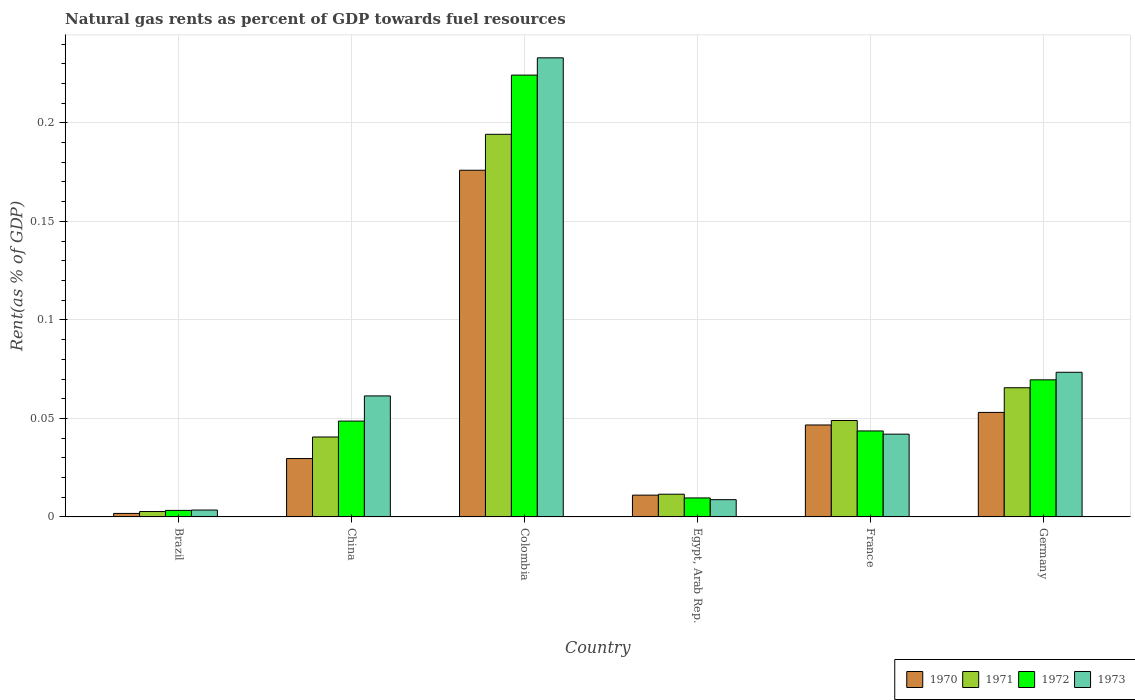How many bars are there on the 6th tick from the left?
Your answer should be very brief. 4. What is the matural gas rent in 1973 in Egypt, Arab Rep.?
Your answer should be very brief. 0.01. Across all countries, what is the maximum matural gas rent in 1970?
Ensure brevity in your answer.  0.18. Across all countries, what is the minimum matural gas rent in 1971?
Ensure brevity in your answer.  0. In which country was the matural gas rent in 1972 maximum?
Provide a short and direct response. Colombia. In which country was the matural gas rent in 1972 minimum?
Provide a succinct answer. Brazil. What is the total matural gas rent in 1970 in the graph?
Provide a succinct answer. 0.32. What is the difference between the matural gas rent in 1973 in Brazil and that in Egypt, Arab Rep.?
Your answer should be very brief. -0.01. What is the difference between the matural gas rent in 1971 in France and the matural gas rent in 1972 in Germany?
Offer a very short reply. -0.02. What is the average matural gas rent in 1970 per country?
Offer a terse response. 0.05. What is the difference between the matural gas rent of/in 1970 and matural gas rent of/in 1971 in China?
Your answer should be very brief. -0.01. In how many countries, is the matural gas rent in 1973 greater than 0.01 %?
Your answer should be compact. 4. What is the ratio of the matural gas rent in 1972 in China to that in Germany?
Keep it short and to the point. 0.7. Is the difference between the matural gas rent in 1970 in Colombia and France greater than the difference between the matural gas rent in 1971 in Colombia and France?
Your answer should be very brief. No. What is the difference between the highest and the second highest matural gas rent in 1972?
Ensure brevity in your answer.  0.15. What is the difference between the highest and the lowest matural gas rent in 1971?
Provide a succinct answer. 0.19. In how many countries, is the matural gas rent in 1973 greater than the average matural gas rent in 1973 taken over all countries?
Provide a short and direct response. 2. What does the 4th bar from the left in Germany represents?
Your response must be concise. 1973. Are all the bars in the graph horizontal?
Provide a short and direct response. No. Where does the legend appear in the graph?
Give a very brief answer. Bottom right. What is the title of the graph?
Your answer should be compact. Natural gas rents as percent of GDP towards fuel resources. Does "1965" appear as one of the legend labels in the graph?
Your answer should be compact. No. What is the label or title of the Y-axis?
Keep it short and to the point. Rent(as % of GDP). What is the Rent(as % of GDP) of 1970 in Brazil?
Your response must be concise. 0. What is the Rent(as % of GDP) in 1971 in Brazil?
Make the answer very short. 0. What is the Rent(as % of GDP) of 1972 in Brazil?
Give a very brief answer. 0. What is the Rent(as % of GDP) of 1973 in Brazil?
Offer a terse response. 0. What is the Rent(as % of GDP) in 1970 in China?
Provide a succinct answer. 0.03. What is the Rent(as % of GDP) of 1971 in China?
Give a very brief answer. 0.04. What is the Rent(as % of GDP) in 1972 in China?
Your response must be concise. 0.05. What is the Rent(as % of GDP) in 1973 in China?
Your answer should be compact. 0.06. What is the Rent(as % of GDP) in 1970 in Colombia?
Offer a very short reply. 0.18. What is the Rent(as % of GDP) of 1971 in Colombia?
Give a very brief answer. 0.19. What is the Rent(as % of GDP) in 1972 in Colombia?
Your response must be concise. 0.22. What is the Rent(as % of GDP) of 1973 in Colombia?
Your answer should be compact. 0.23. What is the Rent(as % of GDP) of 1970 in Egypt, Arab Rep.?
Your answer should be compact. 0.01. What is the Rent(as % of GDP) of 1971 in Egypt, Arab Rep.?
Your response must be concise. 0.01. What is the Rent(as % of GDP) of 1972 in Egypt, Arab Rep.?
Your response must be concise. 0.01. What is the Rent(as % of GDP) of 1973 in Egypt, Arab Rep.?
Keep it short and to the point. 0.01. What is the Rent(as % of GDP) in 1970 in France?
Keep it short and to the point. 0.05. What is the Rent(as % of GDP) of 1971 in France?
Ensure brevity in your answer.  0.05. What is the Rent(as % of GDP) of 1972 in France?
Make the answer very short. 0.04. What is the Rent(as % of GDP) of 1973 in France?
Offer a very short reply. 0.04. What is the Rent(as % of GDP) of 1970 in Germany?
Offer a very short reply. 0.05. What is the Rent(as % of GDP) of 1971 in Germany?
Provide a succinct answer. 0.07. What is the Rent(as % of GDP) in 1972 in Germany?
Offer a very short reply. 0.07. What is the Rent(as % of GDP) in 1973 in Germany?
Keep it short and to the point. 0.07. Across all countries, what is the maximum Rent(as % of GDP) in 1970?
Provide a succinct answer. 0.18. Across all countries, what is the maximum Rent(as % of GDP) in 1971?
Your response must be concise. 0.19. Across all countries, what is the maximum Rent(as % of GDP) in 1972?
Provide a succinct answer. 0.22. Across all countries, what is the maximum Rent(as % of GDP) of 1973?
Offer a very short reply. 0.23. Across all countries, what is the minimum Rent(as % of GDP) of 1970?
Offer a terse response. 0. Across all countries, what is the minimum Rent(as % of GDP) of 1971?
Provide a succinct answer. 0. Across all countries, what is the minimum Rent(as % of GDP) of 1972?
Provide a short and direct response. 0. Across all countries, what is the minimum Rent(as % of GDP) of 1973?
Ensure brevity in your answer.  0. What is the total Rent(as % of GDP) in 1970 in the graph?
Keep it short and to the point. 0.32. What is the total Rent(as % of GDP) of 1971 in the graph?
Keep it short and to the point. 0.36. What is the total Rent(as % of GDP) of 1972 in the graph?
Ensure brevity in your answer.  0.4. What is the total Rent(as % of GDP) of 1973 in the graph?
Provide a short and direct response. 0.42. What is the difference between the Rent(as % of GDP) in 1970 in Brazil and that in China?
Provide a succinct answer. -0.03. What is the difference between the Rent(as % of GDP) in 1971 in Brazil and that in China?
Offer a terse response. -0.04. What is the difference between the Rent(as % of GDP) in 1972 in Brazil and that in China?
Make the answer very short. -0.05. What is the difference between the Rent(as % of GDP) of 1973 in Brazil and that in China?
Your answer should be compact. -0.06. What is the difference between the Rent(as % of GDP) of 1970 in Brazil and that in Colombia?
Your answer should be compact. -0.17. What is the difference between the Rent(as % of GDP) in 1971 in Brazil and that in Colombia?
Ensure brevity in your answer.  -0.19. What is the difference between the Rent(as % of GDP) of 1972 in Brazil and that in Colombia?
Give a very brief answer. -0.22. What is the difference between the Rent(as % of GDP) in 1973 in Brazil and that in Colombia?
Give a very brief answer. -0.23. What is the difference between the Rent(as % of GDP) of 1970 in Brazil and that in Egypt, Arab Rep.?
Make the answer very short. -0.01. What is the difference between the Rent(as % of GDP) in 1971 in Brazil and that in Egypt, Arab Rep.?
Your response must be concise. -0.01. What is the difference between the Rent(as % of GDP) of 1972 in Brazil and that in Egypt, Arab Rep.?
Ensure brevity in your answer.  -0.01. What is the difference between the Rent(as % of GDP) in 1973 in Brazil and that in Egypt, Arab Rep.?
Your response must be concise. -0.01. What is the difference between the Rent(as % of GDP) in 1970 in Brazil and that in France?
Your answer should be compact. -0.04. What is the difference between the Rent(as % of GDP) of 1971 in Brazil and that in France?
Give a very brief answer. -0.05. What is the difference between the Rent(as % of GDP) in 1972 in Brazil and that in France?
Make the answer very short. -0.04. What is the difference between the Rent(as % of GDP) of 1973 in Brazil and that in France?
Your answer should be compact. -0.04. What is the difference between the Rent(as % of GDP) in 1970 in Brazil and that in Germany?
Make the answer very short. -0.05. What is the difference between the Rent(as % of GDP) in 1971 in Brazil and that in Germany?
Your answer should be very brief. -0.06. What is the difference between the Rent(as % of GDP) in 1972 in Brazil and that in Germany?
Offer a terse response. -0.07. What is the difference between the Rent(as % of GDP) of 1973 in Brazil and that in Germany?
Ensure brevity in your answer.  -0.07. What is the difference between the Rent(as % of GDP) in 1970 in China and that in Colombia?
Provide a short and direct response. -0.15. What is the difference between the Rent(as % of GDP) of 1971 in China and that in Colombia?
Make the answer very short. -0.15. What is the difference between the Rent(as % of GDP) of 1972 in China and that in Colombia?
Your response must be concise. -0.18. What is the difference between the Rent(as % of GDP) of 1973 in China and that in Colombia?
Provide a short and direct response. -0.17. What is the difference between the Rent(as % of GDP) of 1970 in China and that in Egypt, Arab Rep.?
Ensure brevity in your answer.  0.02. What is the difference between the Rent(as % of GDP) of 1971 in China and that in Egypt, Arab Rep.?
Offer a very short reply. 0.03. What is the difference between the Rent(as % of GDP) in 1972 in China and that in Egypt, Arab Rep.?
Ensure brevity in your answer.  0.04. What is the difference between the Rent(as % of GDP) of 1973 in China and that in Egypt, Arab Rep.?
Keep it short and to the point. 0.05. What is the difference between the Rent(as % of GDP) of 1970 in China and that in France?
Keep it short and to the point. -0.02. What is the difference between the Rent(as % of GDP) of 1971 in China and that in France?
Your answer should be very brief. -0.01. What is the difference between the Rent(as % of GDP) of 1972 in China and that in France?
Give a very brief answer. 0.01. What is the difference between the Rent(as % of GDP) in 1973 in China and that in France?
Offer a terse response. 0.02. What is the difference between the Rent(as % of GDP) of 1970 in China and that in Germany?
Your answer should be compact. -0.02. What is the difference between the Rent(as % of GDP) of 1971 in China and that in Germany?
Your answer should be very brief. -0.03. What is the difference between the Rent(as % of GDP) of 1972 in China and that in Germany?
Offer a very short reply. -0.02. What is the difference between the Rent(as % of GDP) of 1973 in China and that in Germany?
Make the answer very short. -0.01. What is the difference between the Rent(as % of GDP) in 1970 in Colombia and that in Egypt, Arab Rep.?
Provide a succinct answer. 0.16. What is the difference between the Rent(as % of GDP) in 1971 in Colombia and that in Egypt, Arab Rep.?
Your answer should be compact. 0.18. What is the difference between the Rent(as % of GDP) in 1972 in Colombia and that in Egypt, Arab Rep.?
Your answer should be very brief. 0.21. What is the difference between the Rent(as % of GDP) in 1973 in Colombia and that in Egypt, Arab Rep.?
Give a very brief answer. 0.22. What is the difference between the Rent(as % of GDP) of 1970 in Colombia and that in France?
Your answer should be compact. 0.13. What is the difference between the Rent(as % of GDP) in 1971 in Colombia and that in France?
Your response must be concise. 0.15. What is the difference between the Rent(as % of GDP) in 1972 in Colombia and that in France?
Your response must be concise. 0.18. What is the difference between the Rent(as % of GDP) in 1973 in Colombia and that in France?
Your answer should be compact. 0.19. What is the difference between the Rent(as % of GDP) of 1970 in Colombia and that in Germany?
Make the answer very short. 0.12. What is the difference between the Rent(as % of GDP) of 1971 in Colombia and that in Germany?
Offer a terse response. 0.13. What is the difference between the Rent(as % of GDP) of 1972 in Colombia and that in Germany?
Offer a terse response. 0.15. What is the difference between the Rent(as % of GDP) of 1973 in Colombia and that in Germany?
Offer a terse response. 0.16. What is the difference between the Rent(as % of GDP) in 1970 in Egypt, Arab Rep. and that in France?
Your answer should be compact. -0.04. What is the difference between the Rent(as % of GDP) of 1971 in Egypt, Arab Rep. and that in France?
Keep it short and to the point. -0.04. What is the difference between the Rent(as % of GDP) of 1972 in Egypt, Arab Rep. and that in France?
Your answer should be very brief. -0.03. What is the difference between the Rent(as % of GDP) in 1973 in Egypt, Arab Rep. and that in France?
Your response must be concise. -0.03. What is the difference between the Rent(as % of GDP) in 1970 in Egypt, Arab Rep. and that in Germany?
Give a very brief answer. -0.04. What is the difference between the Rent(as % of GDP) of 1971 in Egypt, Arab Rep. and that in Germany?
Your answer should be compact. -0.05. What is the difference between the Rent(as % of GDP) in 1972 in Egypt, Arab Rep. and that in Germany?
Give a very brief answer. -0.06. What is the difference between the Rent(as % of GDP) of 1973 in Egypt, Arab Rep. and that in Germany?
Provide a short and direct response. -0.06. What is the difference between the Rent(as % of GDP) in 1970 in France and that in Germany?
Offer a terse response. -0.01. What is the difference between the Rent(as % of GDP) of 1971 in France and that in Germany?
Your answer should be compact. -0.02. What is the difference between the Rent(as % of GDP) in 1972 in France and that in Germany?
Keep it short and to the point. -0.03. What is the difference between the Rent(as % of GDP) of 1973 in France and that in Germany?
Offer a very short reply. -0.03. What is the difference between the Rent(as % of GDP) in 1970 in Brazil and the Rent(as % of GDP) in 1971 in China?
Provide a short and direct response. -0.04. What is the difference between the Rent(as % of GDP) in 1970 in Brazil and the Rent(as % of GDP) in 1972 in China?
Your response must be concise. -0.05. What is the difference between the Rent(as % of GDP) of 1970 in Brazil and the Rent(as % of GDP) of 1973 in China?
Your answer should be compact. -0.06. What is the difference between the Rent(as % of GDP) of 1971 in Brazil and the Rent(as % of GDP) of 1972 in China?
Give a very brief answer. -0.05. What is the difference between the Rent(as % of GDP) of 1971 in Brazil and the Rent(as % of GDP) of 1973 in China?
Offer a terse response. -0.06. What is the difference between the Rent(as % of GDP) in 1972 in Brazil and the Rent(as % of GDP) in 1973 in China?
Make the answer very short. -0.06. What is the difference between the Rent(as % of GDP) in 1970 in Brazil and the Rent(as % of GDP) in 1971 in Colombia?
Ensure brevity in your answer.  -0.19. What is the difference between the Rent(as % of GDP) of 1970 in Brazil and the Rent(as % of GDP) of 1972 in Colombia?
Provide a short and direct response. -0.22. What is the difference between the Rent(as % of GDP) in 1970 in Brazil and the Rent(as % of GDP) in 1973 in Colombia?
Ensure brevity in your answer.  -0.23. What is the difference between the Rent(as % of GDP) of 1971 in Brazil and the Rent(as % of GDP) of 1972 in Colombia?
Provide a short and direct response. -0.22. What is the difference between the Rent(as % of GDP) in 1971 in Brazil and the Rent(as % of GDP) in 1973 in Colombia?
Ensure brevity in your answer.  -0.23. What is the difference between the Rent(as % of GDP) in 1972 in Brazil and the Rent(as % of GDP) in 1973 in Colombia?
Your response must be concise. -0.23. What is the difference between the Rent(as % of GDP) in 1970 in Brazil and the Rent(as % of GDP) in 1971 in Egypt, Arab Rep.?
Provide a succinct answer. -0.01. What is the difference between the Rent(as % of GDP) of 1970 in Brazil and the Rent(as % of GDP) of 1972 in Egypt, Arab Rep.?
Make the answer very short. -0.01. What is the difference between the Rent(as % of GDP) in 1970 in Brazil and the Rent(as % of GDP) in 1973 in Egypt, Arab Rep.?
Provide a succinct answer. -0.01. What is the difference between the Rent(as % of GDP) in 1971 in Brazil and the Rent(as % of GDP) in 1972 in Egypt, Arab Rep.?
Offer a terse response. -0.01. What is the difference between the Rent(as % of GDP) in 1971 in Brazil and the Rent(as % of GDP) in 1973 in Egypt, Arab Rep.?
Make the answer very short. -0.01. What is the difference between the Rent(as % of GDP) of 1972 in Brazil and the Rent(as % of GDP) of 1973 in Egypt, Arab Rep.?
Give a very brief answer. -0.01. What is the difference between the Rent(as % of GDP) of 1970 in Brazil and the Rent(as % of GDP) of 1971 in France?
Keep it short and to the point. -0.05. What is the difference between the Rent(as % of GDP) in 1970 in Brazil and the Rent(as % of GDP) in 1972 in France?
Provide a succinct answer. -0.04. What is the difference between the Rent(as % of GDP) in 1970 in Brazil and the Rent(as % of GDP) in 1973 in France?
Offer a terse response. -0.04. What is the difference between the Rent(as % of GDP) of 1971 in Brazil and the Rent(as % of GDP) of 1972 in France?
Keep it short and to the point. -0.04. What is the difference between the Rent(as % of GDP) in 1971 in Brazil and the Rent(as % of GDP) in 1973 in France?
Give a very brief answer. -0.04. What is the difference between the Rent(as % of GDP) of 1972 in Brazil and the Rent(as % of GDP) of 1973 in France?
Offer a very short reply. -0.04. What is the difference between the Rent(as % of GDP) in 1970 in Brazil and the Rent(as % of GDP) in 1971 in Germany?
Ensure brevity in your answer.  -0.06. What is the difference between the Rent(as % of GDP) in 1970 in Brazil and the Rent(as % of GDP) in 1972 in Germany?
Provide a succinct answer. -0.07. What is the difference between the Rent(as % of GDP) of 1970 in Brazil and the Rent(as % of GDP) of 1973 in Germany?
Ensure brevity in your answer.  -0.07. What is the difference between the Rent(as % of GDP) of 1971 in Brazil and the Rent(as % of GDP) of 1972 in Germany?
Offer a very short reply. -0.07. What is the difference between the Rent(as % of GDP) of 1971 in Brazil and the Rent(as % of GDP) of 1973 in Germany?
Keep it short and to the point. -0.07. What is the difference between the Rent(as % of GDP) in 1972 in Brazil and the Rent(as % of GDP) in 1973 in Germany?
Offer a very short reply. -0.07. What is the difference between the Rent(as % of GDP) in 1970 in China and the Rent(as % of GDP) in 1971 in Colombia?
Your answer should be very brief. -0.16. What is the difference between the Rent(as % of GDP) of 1970 in China and the Rent(as % of GDP) of 1972 in Colombia?
Your response must be concise. -0.19. What is the difference between the Rent(as % of GDP) in 1970 in China and the Rent(as % of GDP) in 1973 in Colombia?
Provide a short and direct response. -0.2. What is the difference between the Rent(as % of GDP) in 1971 in China and the Rent(as % of GDP) in 1972 in Colombia?
Your answer should be very brief. -0.18. What is the difference between the Rent(as % of GDP) in 1971 in China and the Rent(as % of GDP) in 1973 in Colombia?
Provide a short and direct response. -0.19. What is the difference between the Rent(as % of GDP) of 1972 in China and the Rent(as % of GDP) of 1973 in Colombia?
Ensure brevity in your answer.  -0.18. What is the difference between the Rent(as % of GDP) of 1970 in China and the Rent(as % of GDP) of 1971 in Egypt, Arab Rep.?
Your answer should be very brief. 0.02. What is the difference between the Rent(as % of GDP) in 1970 in China and the Rent(as % of GDP) in 1972 in Egypt, Arab Rep.?
Ensure brevity in your answer.  0.02. What is the difference between the Rent(as % of GDP) of 1970 in China and the Rent(as % of GDP) of 1973 in Egypt, Arab Rep.?
Offer a very short reply. 0.02. What is the difference between the Rent(as % of GDP) in 1971 in China and the Rent(as % of GDP) in 1972 in Egypt, Arab Rep.?
Provide a succinct answer. 0.03. What is the difference between the Rent(as % of GDP) in 1971 in China and the Rent(as % of GDP) in 1973 in Egypt, Arab Rep.?
Your answer should be compact. 0.03. What is the difference between the Rent(as % of GDP) of 1972 in China and the Rent(as % of GDP) of 1973 in Egypt, Arab Rep.?
Keep it short and to the point. 0.04. What is the difference between the Rent(as % of GDP) of 1970 in China and the Rent(as % of GDP) of 1971 in France?
Your answer should be very brief. -0.02. What is the difference between the Rent(as % of GDP) of 1970 in China and the Rent(as % of GDP) of 1972 in France?
Give a very brief answer. -0.01. What is the difference between the Rent(as % of GDP) of 1970 in China and the Rent(as % of GDP) of 1973 in France?
Give a very brief answer. -0.01. What is the difference between the Rent(as % of GDP) of 1971 in China and the Rent(as % of GDP) of 1972 in France?
Provide a short and direct response. -0. What is the difference between the Rent(as % of GDP) of 1971 in China and the Rent(as % of GDP) of 1973 in France?
Offer a terse response. -0. What is the difference between the Rent(as % of GDP) in 1972 in China and the Rent(as % of GDP) in 1973 in France?
Keep it short and to the point. 0.01. What is the difference between the Rent(as % of GDP) in 1970 in China and the Rent(as % of GDP) in 1971 in Germany?
Ensure brevity in your answer.  -0.04. What is the difference between the Rent(as % of GDP) in 1970 in China and the Rent(as % of GDP) in 1972 in Germany?
Keep it short and to the point. -0.04. What is the difference between the Rent(as % of GDP) of 1970 in China and the Rent(as % of GDP) of 1973 in Germany?
Provide a short and direct response. -0.04. What is the difference between the Rent(as % of GDP) of 1971 in China and the Rent(as % of GDP) of 1972 in Germany?
Offer a terse response. -0.03. What is the difference between the Rent(as % of GDP) of 1971 in China and the Rent(as % of GDP) of 1973 in Germany?
Keep it short and to the point. -0.03. What is the difference between the Rent(as % of GDP) in 1972 in China and the Rent(as % of GDP) in 1973 in Germany?
Keep it short and to the point. -0.02. What is the difference between the Rent(as % of GDP) in 1970 in Colombia and the Rent(as % of GDP) in 1971 in Egypt, Arab Rep.?
Your answer should be very brief. 0.16. What is the difference between the Rent(as % of GDP) in 1970 in Colombia and the Rent(as % of GDP) in 1972 in Egypt, Arab Rep.?
Provide a short and direct response. 0.17. What is the difference between the Rent(as % of GDP) of 1970 in Colombia and the Rent(as % of GDP) of 1973 in Egypt, Arab Rep.?
Your answer should be very brief. 0.17. What is the difference between the Rent(as % of GDP) in 1971 in Colombia and the Rent(as % of GDP) in 1972 in Egypt, Arab Rep.?
Give a very brief answer. 0.18. What is the difference between the Rent(as % of GDP) in 1971 in Colombia and the Rent(as % of GDP) in 1973 in Egypt, Arab Rep.?
Your response must be concise. 0.19. What is the difference between the Rent(as % of GDP) in 1972 in Colombia and the Rent(as % of GDP) in 1973 in Egypt, Arab Rep.?
Offer a very short reply. 0.22. What is the difference between the Rent(as % of GDP) in 1970 in Colombia and the Rent(as % of GDP) in 1971 in France?
Give a very brief answer. 0.13. What is the difference between the Rent(as % of GDP) in 1970 in Colombia and the Rent(as % of GDP) in 1972 in France?
Offer a very short reply. 0.13. What is the difference between the Rent(as % of GDP) of 1970 in Colombia and the Rent(as % of GDP) of 1973 in France?
Give a very brief answer. 0.13. What is the difference between the Rent(as % of GDP) in 1971 in Colombia and the Rent(as % of GDP) in 1972 in France?
Your answer should be very brief. 0.15. What is the difference between the Rent(as % of GDP) in 1971 in Colombia and the Rent(as % of GDP) in 1973 in France?
Your answer should be compact. 0.15. What is the difference between the Rent(as % of GDP) of 1972 in Colombia and the Rent(as % of GDP) of 1973 in France?
Provide a short and direct response. 0.18. What is the difference between the Rent(as % of GDP) of 1970 in Colombia and the Rent(as % of GDP) of 1971 in Germany?
Your answer should be very brief. 0.11. What is the difference between the Rent(as % of GDP) in 1970 in Colombia and the Rent(as % of GDP) in 1972 in Germany?
Give a very brief answer. 0.11. What is the difference between the Rent(as % of GDP) in 1970 in Colombia and the Rent(as % of GDP) in 1973 in Germany?
Offer a very short reply. 0.1. What is the difference between the Rent(as % of GDP) of 1971 in Colombia and the Rent(as % of GDP) of 1972 in Germany?
Offer a very short reply. 0.12. What is the difference between the Rent(as % of GDP) of 1971 in Colombia and the Rent(as % of GDP) of 1973 in Germany?
Give a very brief answer. 0.12. What is the difference between the Rent(as % of GDP) of 1972 in Colombia and the Rent(as % of GDP) of 1973 in Germany?
Give a very brief answer. 0.15. What is the difference between the Rent(as % of GDP) in 1970 in Egypt, Arab Rep. and the Rent(as % of GDP) in 1971 in France?
Provide a short and direct response. -0.04. What is the difference between the Rent(as % of GDP) of 1970 in Egypt, Arab Rep. and the Rent(as % of GDP) of 1972 in France?
Offer a terse response. -0.03. What is the difference between the Rent(as % of GDP) of 1970 in Egypt, Arab Rep. and the Rent(as % of GDP) of 1973 in France?
Keep it short and to the point. -0.03. What is the difference between the Rent(as % of GDP) of 1971 in Egypt, Arab Rep. and the Rent(as % of GDP) of 1972 in France?
Make the answer very short. -0.03. What is the difference between the Rent(as % of GDP) of 1971 in Egypt, Arab Rep. and the Rent(as % of GDP) of 1973 in France?
Keep it short and to the point. -0.03. What is the difference between the Rent(as % of GDP) in 1972 in Egypt, Arab Rep. and the Rent(as % of GDP) in 1973 in France?
Provide a short and direct response. -0.03. What is the difference between the Rent(as % of GDP) of 1970 in Egypt, Arab Rep. and the Rent(as % of GDP) of 1971 in Germany?
Give a very brief answer. -0.05. What is the difference between the Rent(as % of GDP) in 1970 in Egypt, Arab Rep. and the Rent(as % of GDP) in 1972 in Germany?
Ensure brevity in your answer.  -0.06. What is the difference between the Rent(as % of GDP) in 1970 in Egypt, Arab Rep. and the Rent(as % of GDP) in 1973 in Germany?
Your answer should be very brief. -0.06. What is the difference between the Rent(as % of GDP) of 1971 in Egypt, Arab Rep. and the Rent(as % of GDP) of 1972 in Germany?
Keep it short and to the point. -0.06. What is the difference between the Rent(as % of GDP) of 1971 in Egypt, Arab Rep. and the Rent(as % of GDP) of 1973 in Germany?
Keep it short and to the point. -0.06. What is the difference between the Rent(as % of GDP) in 1972 in Egypt, Arab Rep. and the Rent(as % of GDP) in 1973 in Germany?
Keep it short and to the point. -0.06. What is the difference between the Rent(as % of GDP) of 1970 in France and the Rent(as % of GDP) of 1971 in Germany?
Provide a succinct answer. -0.02. What is the difference between the Rent(as % of GDP) in 1970 in France and the Rent(as % of GDP) in 1972 in Germany?
Keep it short and to the point. -0.02. What is the difference between the Rent(as % of GDP) of 1970 in France and the Rent(as % of GDP) of 1973 in Germany?
Provide a short and direct response. -0.03. What is the difference between the Rent(as % of GDP) in 1971 in France and the Rent(as % of GDP) in 1972 in Germany?
Your answer should be compact. -0.02. What is the difference between the Rent(as % of GDP) in 1971 in France and the Rent(as % of GDP) in 1973 in Germany?
Offer a very short reply. -0.02. What is the difference between the Rent(as % of GDP) of 1972 in France and the Rent(as % of GDP) of 1973 in Germany?
Offer a very short reply. -0.03. What is the average Rent(as % of GDP) in 1970 per country?
Your answer should be compact. 0.05. What is the average Rent(as % of GDP) of 1971 per country?
Make the answer very short. 0.06. What is the average Rent(as % of GDP) of 1972 per country?
Provide a short and direct response. 0.07. What is the average Rent(as % of GDP) in 1973 per country?
Your answer should be compact. 0.07. What is the difference between the Rent(as % of GDP) in 1970 and Rent(as % of GDP) in 1971 in Brazil?
Your answer should be very brief. -0. What is the difference between the Rent(as % of GDP) in 1970 and Rent(as % of GDP) in 1972 in Brazil?
Give a very brief answer. -0. What is the difference between the Rent(as % of GDP) of 1970 and Rent(as % of GDP) of 1973 in Brazil?
Keep it short and to the point. -0. What is the difference between the Rent(as % of GDP) in 1971 and Rent(as % of GDP) in 1972 in Brazil?
Keep it short and to the point. -0. What is the difference between the Rent(as % of GDP) of 1971 and Rent(as % of GDP) of 1973 in Brazil?
Provide a short and direct response. -0. What is the difference between the Rent(as % of GDP) in 1972 and Rent(as % of GDP) in 1973 in Brazil?
Your answer should be compact. -0. What is the difference between the Rent(as % of GDP) of 1970 and Rent(as % of GDP) of 1971 in China?
Your answer should be compact. -0.01. What is the difference between the Rent(as % of GDP) in 1970 and Rent(as % of GDP) in 1972 in China?
Ensure brevity in your answer.  -0.02. What is the difference between the Rent(as % of GDP) of 1970 and Rent(as % of GDP) of 1973 in China?
Keep it short and to the point. -0.03. What is the difference between the Rent(as % of GDP) in 1971 and Rent(as % of GDP) in 1972 in China?
Provide a succinct answer. -0.01. What is the difference between the Rent(as % of GDP) in 1971 and Rent(as % of GDP) in 1973 in China?
Offer a very short reply. -0.02. What is the difference between the Rent(as % of GDP) of 1972 and Rent(as % of GDP) of 1973 in China?
Your answer should be very brief. -0.01. What is the difference between the Rent(as % of GDP) of 1970 and Rent(as % of GDP) of 1971 in Colombia?
Keep it short and to the point. -0.02. What is the difference between the Rent(as % of GDP) of 1970 and Rent(as % of GDP) of 1972 in Colombia?
Offer a terse response. -0.05. What is the difference between the Rent(as % of GDP) in 1970 and Rent(as % of GDP) in 1973 in Colombia?
Ensure brevity in your answer.  -0.06. What is the difference between the Rent(as % of GDP) in 1971 and Rent(as % of GDP) in 1972 in Colombia?
Keep it short and to the point. -0.03. What is the difference between the Rent(as % of GDP) of 1971 and Rent(as % of GDP) of 1973 in Colombia?
Provide a succinct answer. -0.04. What is the difference between the Rent(as % of GDP) of 1972 and Rent(as % of GDP) of 1973 in Colombia?
Offer a terse response. -0.01. What is the difference between the Rent(as % of GDP) of 1970 and Rent(as % of GDP) of 1971 in Egypt, Arab Rep.?
Provide a succinct answer. -0. What is the difference between the Rent(as % of GDP) in 1970 and Rent(as % of GDP) in 1972 in Egypt, Arab Rep.?
Give a very brief answer. 0. What is the difference between the Rent(as % of GDP) in 1970 and Rent(as % of GDP) in 1973 in Egypt, Arab Rep.?
Provide a succinct answer. 0. What is the difference between the Rent(as % of GDP) of 1971 and Rent(as % of GDP) of 1972 in Egypt, Arab Rep.?
Ensure brevity in your answer.  0. What is the difference between the Rent(as % of GDP) in 1971 and Rent(as % of GDP) in 1973 in Egypt, Arab Rep.?
Give a very brief answer. 0. What is the difference between the Rent(as % of GDP) in 1972 and Rent(as % of GDP) in 1973 in Egypt, Arab Rep.?
Ensure brevity in your answer.  0. What is the difference between the Rent(as % of GDP) in 1970 and Rent(as % of GDP) in 1971 in France?
Your response must be concise. -0. What is the difference between the Rent(as % of GDP) of 1970 and Rent(as % of GDP) of 1972 in France?
Your response must be concise. 0. What is the difference between the Rent(as % of GDP) in 1970 and Rent(as % of GDP) in 1973 in France?
Make the answer very short. 0. What is the difference between the Rent(as % of GDP) of 1971 and Rent(as % of GDP) of 1972 in France?
Make the answer very short. 0.01. What is the difference between the Rent(as % of GDP) of 1971 and Rent(as % of GDP) of 1973 in France?
Offer a very short reply. 0.01. What is the difference between the Rent(as % of GDP) of 1972 and Rent(as % of GDP) of 1973 in France?
Keep it short and to the point. 0. What is the difference between the Rent(as % of GDP) of 1970 and Rent(as % of GDP) of 1971 in Germany?
Offer a terse response. -0.01. What is the difference between the Rent(as % of GDP) in 1970 and Rent(as % of GDP) in 1972 in Germany?
Make the answer very short. -0.02. What is the difference between the Rent(as % of GDP) in 1970 and Rent(as % of GDP) in 1973 in Germany?
Your response must be concise. -0.02. What is the difference between the Rent(as % of GDP) of 1971 and Rent(as % of GDP) of 1972 in Germany?
Your answer should be compact. -0. What is the difference between the Rent(as % of GDP) in 1971 and Rent(as % of GDP) in 1973 in Germany?
Ensure brevity in your answer.  -0.01. What is the difference between the Rent(as % of GDP) in 1972 and Rent(as % of GDP) in 1973 in Germany?
Your response must be concise. -0. What is the ratio of the Rent(as % of GDP) of 1971 in Brazil to that in China?
Keep it short and to the point. 0.07. What is the ratio of the Rent(as % of GDP) of 1972 in Brazil to that in China?
Your response must be concise. 0.07. What is the ratio of the Rent(as % of GDP) in 1973 in Brazil to that in China?
Offer a terse response. 0.06. What is the ratio of the Rent(as % of GDP) in 1970 in Brazil to that in Colombia?
Offer a terse response. 0.01. What is the ratio of the Rent(as % of GDP) in 1971 in Brazil to that in Colombia?
Provide a short and direct response. 0.01. What is the ratio of the Rent(as % of GDP) of 1972 in Brazil to that in Colombia?
Offer a very short reply. 0.01. What is the ratio of the Rent(as % of GDP) of 1973 in Brazil to that in Colombia?
Offer a very short reply. 0.01. What is the ratio of the Rent(as % of GDP) in 1970 in Brazil to that in Egypt, Arab Rep.?
Your answer should be very brief. 0.16. What is the ratio of the Rent(as % of GDP) of 1971 in Brazil to that in Egypt, Arab Rep.?
Make the answer very short. 0.24. What is the ratio of the Rent(as % of GDP) of 1972 in Brazil to that in Egypt, Arab Rep.?
Your answer should be compact. 0.34. What is the ratio of the Rent(as % of GDP) in 1973 in Brazil to that in Egypt, Arab Rep.?
Keep it short and to the point. 0.4. What is the ratio of the Rent(as % of GDP) of 1970 in Brazil to that in France?
Keep it short and to the point. 0.04. What is the ratio of the Rent(as % of GDP) in 1971 in Brazil to that in France?
Make the answer very short. 0.06. What is the ratio of the Rent(as % of GDP) of 1972 in Brazil to that in France?
Provide a short and direct response. 0.08. What is the ratio of the Rent(as % of GDP) in 1973 in Brazil to that in France?
Your response must be concise. 0.08. What is the ratio of the Rent(as % of GDP) of 1970 in Brazil to that in Germany?
Provide a succinct answer. 0.03. What is the ratio of the Rent(as % of GDP) in 1971 in Brazil to that in Germany?
Provide a succinct answer. 0.04. What is the ratio of the Rent(as % of GDP) of 1972 in Brazil to that in Germany?
Make the answer very short. 0.05. What is the ratio of the Rent(as % of GDP) in 1973 in Brazil to that in Germany?
Your answer should be compact. 0.05. What is the ratio of the Rent(as % of GDP) of 1970 in China to that in Colombia?
Your answer should be very brief. 0.17. What is the ratio of the Rent(as % of GDP) of 1971 in China to that in Colombia?
Your answer should be compact. 0.21. What is the ratio of the Rent(as % of GDP) of 1972 in China to that in Colombia?
Keep it short and to the point. 0.22. What is the ratio of the Rent(as % of GDP) in 1973 in China to that in Colombia?
Your answer should be very brief. 0.26. What is the ratio of the Rent(as % of GDP) in 1970 in China to that in Egypt, Arab Rep.?
Give a very brief answer. 2.68. What is the ratio of the Rent(as % of GDP) in 1971 in China to that in Egypt, Arab Rep.?
Ensure brevity in your answer.  3.52. What is the ratio of the Rent(as % of GDP) of 1972 in China to that in Egypt, Arab Rep.?
Make the answer very short. 5.04. What is the ratio of the Rent(as % of GDP) of 1973 in China to that in Egypt, Arab Rep.?
Ensure brevity in your answer.  7.01. What is the ratio of the Rent(as % of GDP) in 1970 in China to that in France?
Ensure brevity in your answer.  0.64. What is the ratio of the Rent(as % of GDP) of 1971 in China to that in France?
Make the answer very short. 0.83. What is the ratio of the Rent(as % of GDP) in 1972 in China to that in France?
Your answer should be compact. 1.11. What is the ratio of the Rent(as % of GDP) of 1973 in China to that in France?
Your response must be concise. 1.46. What is the ratio of the Rent(as % of GDP) in 1970 in China to that in Germany?
Your answer should be compact. 0.56. What is the ratio of the Rent(as % of GDP) in 1971 in China to that in Germany?
Give a very brief answer. 0.62. What is the ratio of the Rent(as % of GDP) of 1972 in China to that in Germany?
Your response must be concise. 0.7. What is the ratio of the Rent(as % of GDP) of 1973 in China to that in Germany?
Your response must be concise. 0.84. What is the ratio of the Rent(as % of GDP) in 1970 in Colombia to that in Egypt, Arab Rep.?
Give a very brief answer. 15.9. What is the ratio of the Rent(as % of GDP) of 1971 in Colombia to that in Egypt, Arab Rep.?
Make the answer very short. 16.84. What is the ratio of the Rent(as % of GDP) in 1972 in Colombia to that in Egypt, Arab Rep.?
Make the answer very short. 23.25. What is the ratio of the Rent(as % of GDP) in 1973 in Colombia to that in Egypt, Arab Rep.?
Offer a very short reply. 26.6. What is the ratio of the Rent(as % of GDP) in 1970 in Colombia to that in France?
Ensure brevity in your answer.  3.77. What is the ratio of the Rent(as % of GDP) of 1971 in Colombia to that in France?
Give a very brief answer. 3.97. What is the ratio of the Rent(as % of GDP) of 1972 in Colombia to that in France?
Give a very brief answer. 5.14. What is the ratio of the Rent(as % of GDP) of 1973 in Colombia to that in France?
Keep it short and to the point. 5.55. What is the ratio of the Rent(as % of GDP) of 1970 in Colombia to that in Germany?
Give a very brief answer. 3.32. What is the ratio of the Rent(as % of GDP) of 1971 in Colombia to that in Germany?
Keep it short and to the point. 2.96. What is the ratio of the Rent(as % of GDP) in 1972 in Colombia to that in Germany?
Ensure brevity in your answer.  3.22. What is the ratio of the Rent(as % of GDP) in 1973 in Colombia to that in Germany?
Your response must be concise. 3.17. What is the ratio of the Rent(as % of GDP) of 1970 in Egypt, Arab Rep. to that in France?
Offer a very short reply. 0.24. What is the ratio of the Rent(as % of GDP) of 1971 in Egypt, Arab Rep. to that in France?
Provide a succinct answer. 0.24. What is the ratio of the Rent(as % of GDP) in 1972 in Egypt, Arab Rep. to that in France?
Your answer should be very brief. 0.22. What is the ratio of the Rent(as % of GDP) in 1973 in Egypt, Arab Rep. to that in France?
Your response must be concise. 0.21. What is the ratio of the Rent(as % of GDP) in 1970 in Egypt, Arab Rep. to that in Germany?
Offer a very short reply. 0.21. What is the ratio of the Rent(as % of GDP) of 1971 in Egypt, Arab Rep. to that in Germany?
Offer a terse response. 0.18. What is the ratio of the Rent(as % of GDP) of 1972 in Egypt, Arab Rep. to that in Germany?
Make the answer very short. 0.14. What is the ratio of the Rent(as % of GDP) in 1973 in Egypt, Arab Rep. to that in Germany?
Offer a terse response. 0.12. What is the ratio of the Rent(as % of GDP) in 1970 in France to that in Germany?
Make the answer very short. 0.88. What is the ratio of the Rent(as % of GDP) of 1971 in France to that in Germany?
Your answer should be compact. 0.75. What is the ratio of the Rent(as % of GDP) in 1972 in France to that in Germany?
Provide a succinct answer. 0.63. What is the ratio of the Rent(as % of GDP) of 1973 in France to that in Germany?
Make the answer very short. 0.57. What is the difference between the highest and the second highest Rent(as % of GDP) of 1970?
Your response must be concise. 0.12. What is the difference between the highest and the second highest Rent(as % of GDP) in 1971?
Your answer should be very brief. 0.13. What is the difference between the highest and the second highest Rent(as % of GDP) of 1972?
Provide a short and direct response. 0.15. What is the difference between the highest and the second highest Rent(as % of GDP) in 1973?
Your answer should be very brief. 0.16. What is the difference between the highest and the lowest Rent(as % of GDP) of 1970?
Keep it short and to the point. 0.17. What is the difference between the highest and the lowest Rent(as % of GDP) of 1971?
Your response must be concise. 0.19. What is the difference between the highest and the lowest Rent(as % of GDP) of 1972?
Provide a short and direct response. 0.22. What is the difference between the highest and the lowest Rent(as % of GDP) of 1973?
Give a very brief answer. 0.23. 